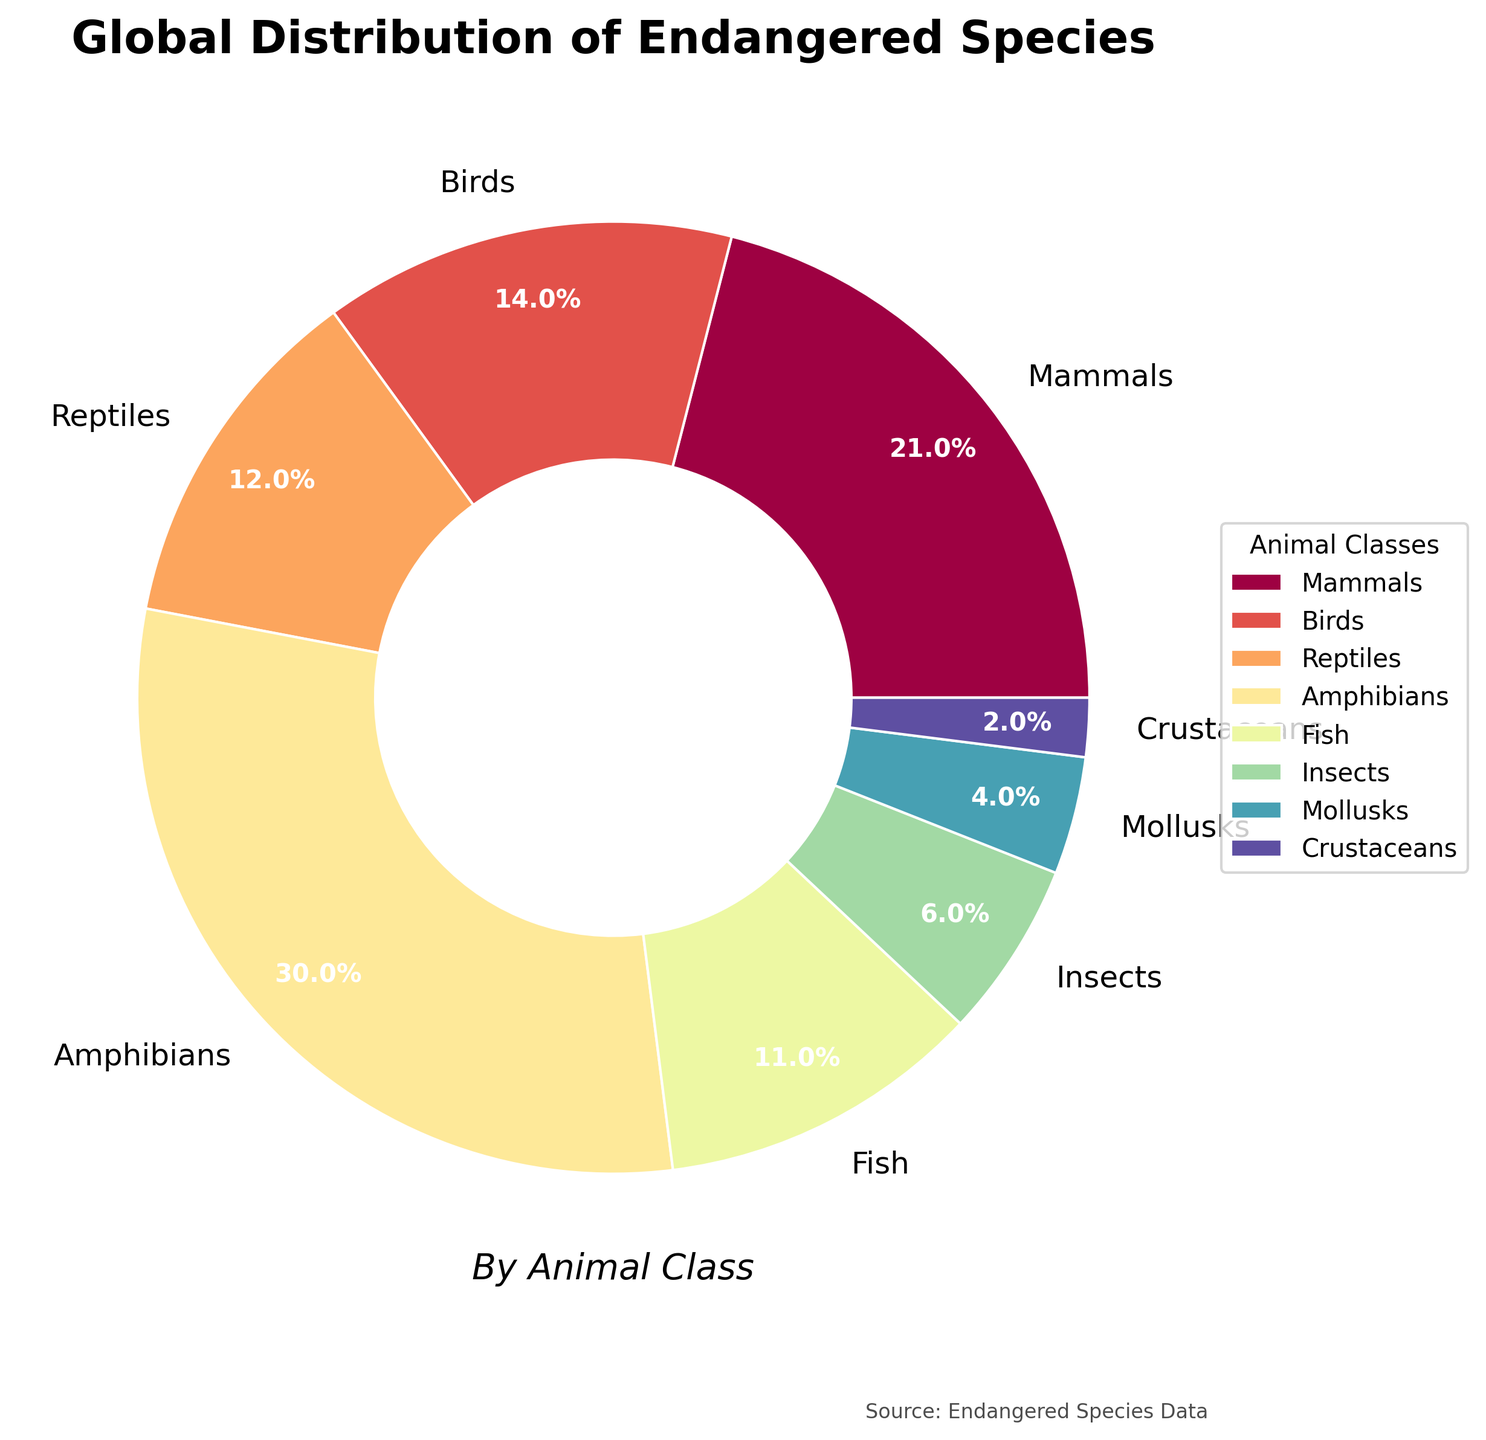What percentage of endangered species are insects? In the pie chart, the label for insects shows their percentage clearly. Upon locating the insect section, it displays "6%".
Answer: 6% How many animal classes have more than 10% of the endangered species? By analyzing each label in the pie chart, we can count the classes with a percentage higher than 10%. Mammals (21%), Birds (14%), Reptiles (12%), Amphibians (30%), Fish (11%) all meet this criterion.
Answer: 5 What is the combined percentage of endangered mammals and birds? We sum up the percentages of mammals (21%) and birds (14%). Therefore, 21 + 14 = 35%.
Answer: 35% Which class has the least percentage of endangered species? Exploring each segment of the pie chart, we identify the smallest segment being Crustaceans, which is labeled as 2%.
Answer: Crustaceans Are amphibians more common than reptiles among endangered species? If so, by how much? Amphibians have 30% and reptiles have 12%. Subtracting the smaller percentage from the larger gives 30 - 12 = 18%. Hence, amphibians are 18% more common.
Answer: 18% Do mammals and fish together account for more or less than 35% of the endangered species? Adding the percentages for mammals (21%) and fish (11%) gives us 21 + 11 = 32%. Since 32% is less than 35%, the combined percentage is less.
Answer: Less What is the average percentage of endangered species among mammals, birds, and fish? We sum the percentages of mammals (21%), birds (14%), and fish (11%) which results in 21 + 14 + 11 = 46. Dividing by 3 gives an average: 46 / 3 = 15.33%.
Answer: 15.33% Which class contributes to the largest chunk of the pie chart? Looking for the largest section in the pie chart leads us to amphibians, which are marked as representing 30%.
Answer: Amphibians If you combine insects and mollusks, do they have a higher percentage than reptiles alone? Insects have 6% and mollusks have 4%, so their combined percentage is 6 + 4 = 10%. Comparing this to reptiles which have 12%, we find that 10% is less than 12%.
Answer: No How many animal classes make up less than 10% each of the endangered species? Analyzing the pie chart, we find Insects (6%), Mollusks (4%), and Crustaceans (2%) make up less than 10%. Therefore, there are three classes.
Answer: 3 